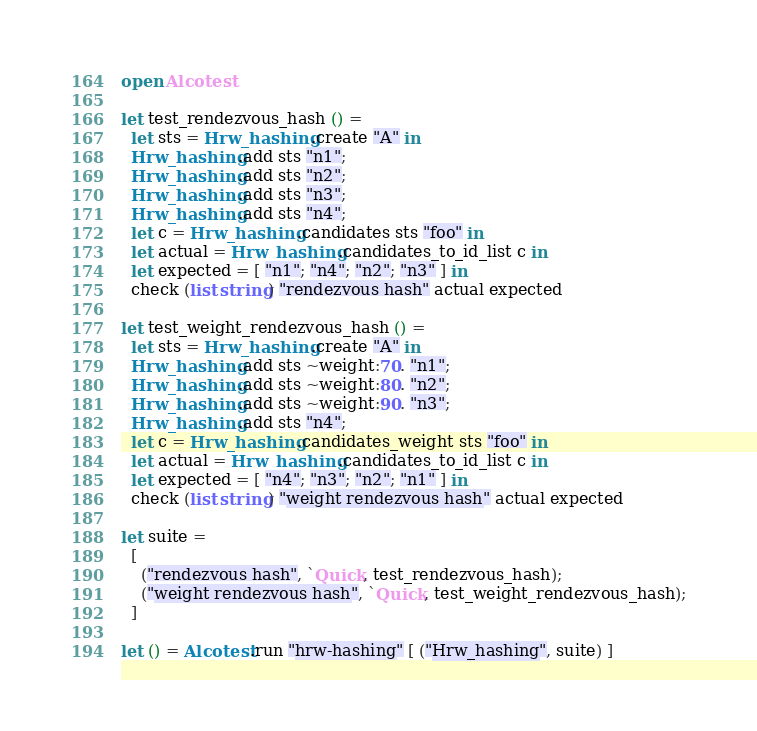<code> <loc_0><loc_0><loc_500><loc_500><_OCaml_>open Alcotest

let test_rendezvous_hash () =
  let sts = Hrw_hashing.create "A" in
  Hrw_hashing.add sts "n1";
  Hrw_hashing.add sts "n2";
  Hrw_hashing.add sts "n3";
  Hrw_hashing.add sts "n4";
  let c = Hrw_hashing.candidates sts "foo" in
  let actual = Hrw_hashing.candidates_to_id_list c in
  let expected = [ "n1"; "n4"; "n2"; "n3" ] in
  check (list string) "rendezvous hash" actual expected

let test_weight_rendezvous_hash () =
  let sts = Hrw_hashing.create "A" in
  Hrw_hashing.add sts ~weight:70. "n1";
  Hrw_hashing.add sts ~weight:80. "n2";
  Hrw_hashing.add sts ~weight:90. "n3";
  Hrw_hashing.add sts "n4";
  let c = Hrw_hashing.candidates_weight sts "foo" in
  let actual = Hrw_hashing.candidates_to_id_list c in
  let expected = [ "n4"; "n3"; "n2"; "n1" ] in
  check (list string) "weight rendezvous hash" actual expected

let suite =
  [
    ("rendezvous hash", `Quick, test_rendezvous_hash);
    ("weight rendezvous hash", `Quick, test_weight_rendezvous_hash);
  ]

let () = Alcotest.run "hrw-hashing" [ ("Hrw_hashing", suite) ]
</code> 